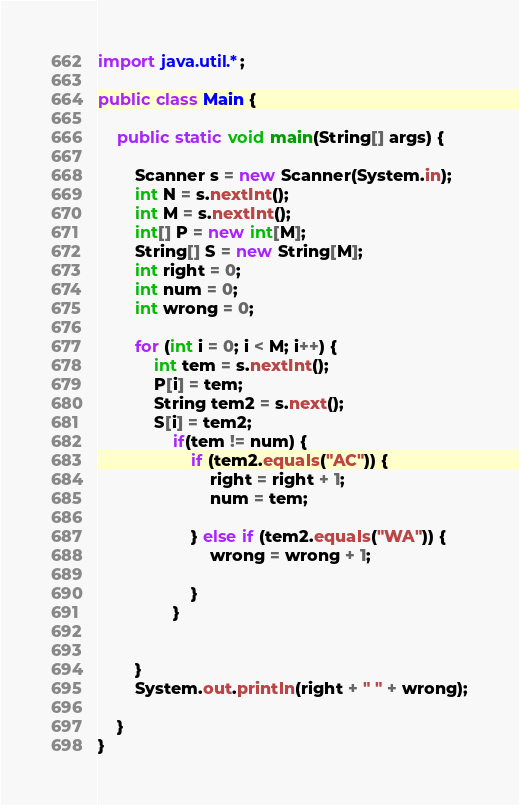<code> <loc_0><loc_0><loc_500><loc_500><_Java_>import java.util.*;

public class Main {

    public static void main(String[] args) {

        Scanner s = new Scanner(System.in);
        int N = s.nextInt();
        int M = s.nextInt();
        int[] P = new int[M];
        String[] S = new String[M];
        int right = 0;
        int num = 0;
        int wrong = 0;

        for (int i = 0; i < M; i++) {
            int tem = s.nextInt();
            P[i] = tem;
            String tem2 = s.next();
            S[i] = tem2;
                if(tem != num) {
                    if (tem2.equals("AC")) {
                        right = right + 1;
                        num = tem;

                    } else if (tem2.equals("WA")) {
                        wrong = wrong + 1;

                    }
                }


        }
        System.out.println(right + " " + wrong);

    }
}

</code> 